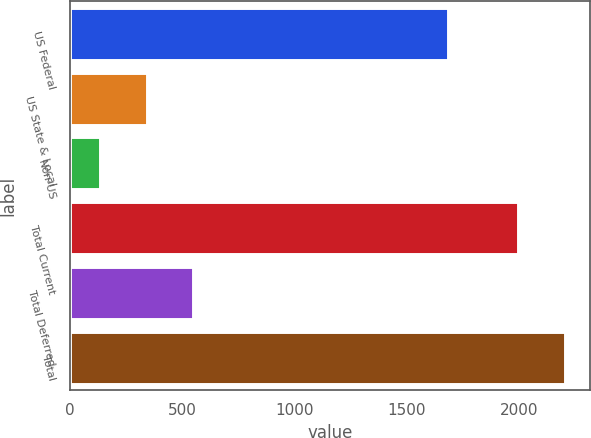Convert chart to OTSL. <chart><loc_0><loc_0><loc_500><loc_500><bar_chart><fcel>US Federal<fcel>US State & Local<fcel>Non-US<fcel>Total Current<fcel>Total Deferred<fcel>Total<nl><fcel>1683<fcel>342<fcel>135<fcel>1994<fcel>549<fcel>2205<nl></chart> 